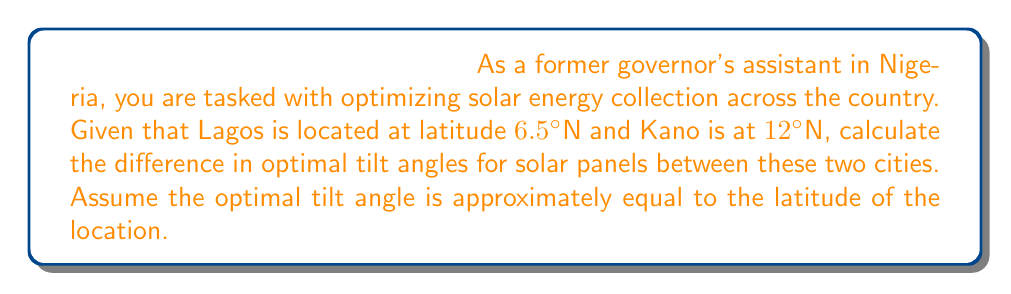Could you help me with this problem? To solve this problem, we need to follow these steps:

1. Identify the latitudes of Lagos and Kano:
   Lagos: 6.5°N
   Kano: 12°N

2. Calculate the optimal tilt angle for each city:
   The optimal tilt angle is approximately equal to the latitude of the location.
   
   For Lagos: $\theta_{Lagos} = 6.5°$
   For Kano: $\theta_{Kano} = 12°$

3. Calculate the difference in optimal tilt angles:
   $$\Delta\theta = \theta_{Kano} - \theta_{Lagos}$$
   $$\Delta\theta = 12° - 6.5°$$
   $$\Delta\theta = 5.5°$$

This result shows that solar panels in Kano should be tilted 5.5° more than those in Lagos to maximize energy collection.

[asy]
import geometry;

size(200);
draw((-1,0)--(11,0),Arrow);
draw((0,-1)--(0,11),Arrow);

label("0°", (0,0), SW);
label("Equator", (11,0), E);

draw((0,0)--(10,6.5),dashed);
draw((0,0)--(10,12),dashed);

label("6.5°", (5,3.25), SE);
label("12°", (5,6), NW);

label("Lagos", (10,6.5), E);
label("Kano", (10,12), E);

draw(arc((0,0),2,0,12),Arrow);
label("5.5°", (1.5,1), NE);
[/asy]
Answer: 5.5° 